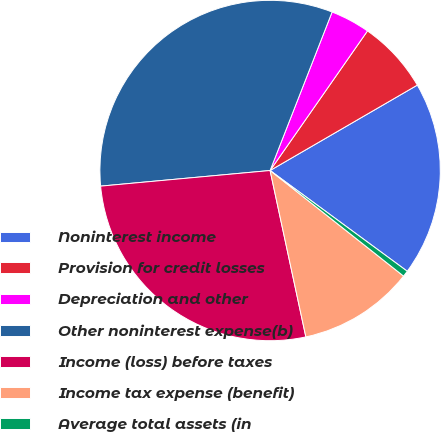Convert chart. <chart><loc_0><loc_0><loc_500><loc_500><pie_chart><fcel>Noninterest income<fcel>Provision for credit losses<fcel>Depreciation and other<fcel>Other noninterest expense(b)<fcel>Income (loss) before taxes<fcel>Income tax expense (benefit)<fcel>Average total assets (in<nl><fcel>18.45%<fcel>6.94%<fcel>3.76%<fcel>32.4%<fcel>26.91%<fcel>10.98%<fcel>0.57%<nl></chart> 